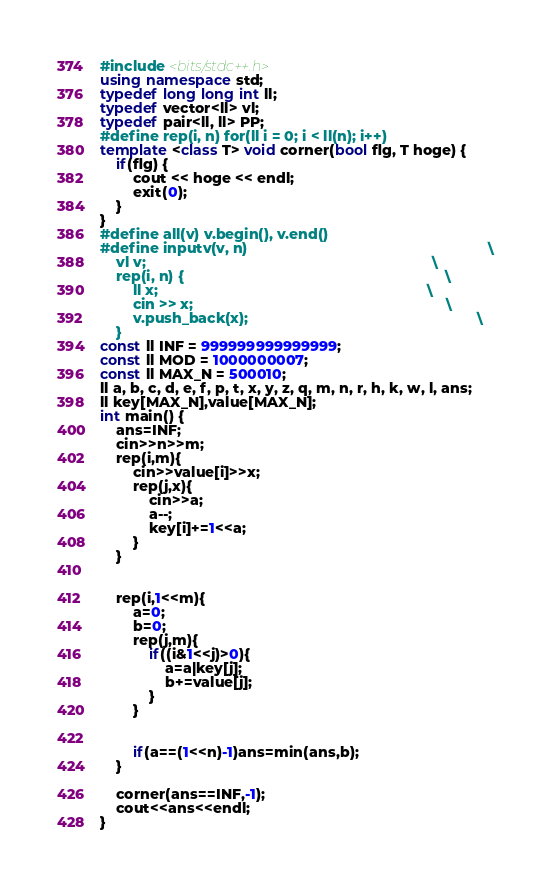<code> <loc_0><loc_0><loc_500><loc_500><_C++_>#include <bits/stdc++.h>
using namespace std;
typedef long long int ll;
typedef vector<ll> vl;
typedef pair<ll, ll> PP;
#define rep(i, n) for(ll i = 0; i < ll(n); i++)
template <class T> void corner(bool flg, T hoge) {
    if(flg) {
        cout << hoge << endl;
        exit(0);
    }
}
#define all(v) v.begin(), v.end()
#define inputv(v, n)                                                           \
    vl v;                                                                      \
    rep(i, n) {                                                                \
        ll x;                                                                  \
        cin >> x;                                                              \
        v.push_back(x);                                                        \
    }
const ll INF = 999999999999999;
const ll MOD = 1000000007;
const ll MAX_N = 500010;
ll a, b, c, d, e, f, p, t, x, y, z, q, m, n, r, h, k, w, l, ans;
ll key[MAX_N],value[MAX_N];
int main() {
    ans=INF;
    cin>>n>>m;
    rep(i,m){
        cin>>value[i]>>x;
        rep(j,x){
            cin>>a;
            a--;
            key[i]+=1<<a;
        }
    }


    rep(i,1<<m){
        a=0;
        b=0;
        rep(j,m){
            if((i&1<<j)>0){
                a=a|key[j];
                b+=value[j];
            }
        }


        if(a==(1<<n)-1)ans=min(ans,b);
    }

    corner(ans==INF,-1);
    cout<<ans<<endl;
}</code> 